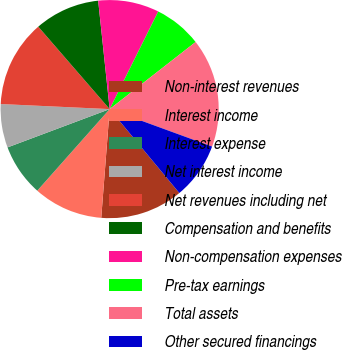Convert chart. <chart><loc_0><loc_0><loc_500><loc_500><pie_chart><fcel>Non-interest revenues<fcel>Interest income<fcel>Interest expense<fcel>Net interest income<fcel>Net revenues including net<fcel>Compensation and benefits<fcel>Non-compensation expenses<fcel>Pre-tax earnings<fcel>Total assets<fcel>Other secured financings<nl><fcel>12.26%<fcel>10.32%<fcel>7.74%<fcel>6.45%<fcel>12.9%<fcel>9.68%<fcel>9.03%<fcel>7.1%<fcel>16.13%<fcel>8.39%<nl></chart> 